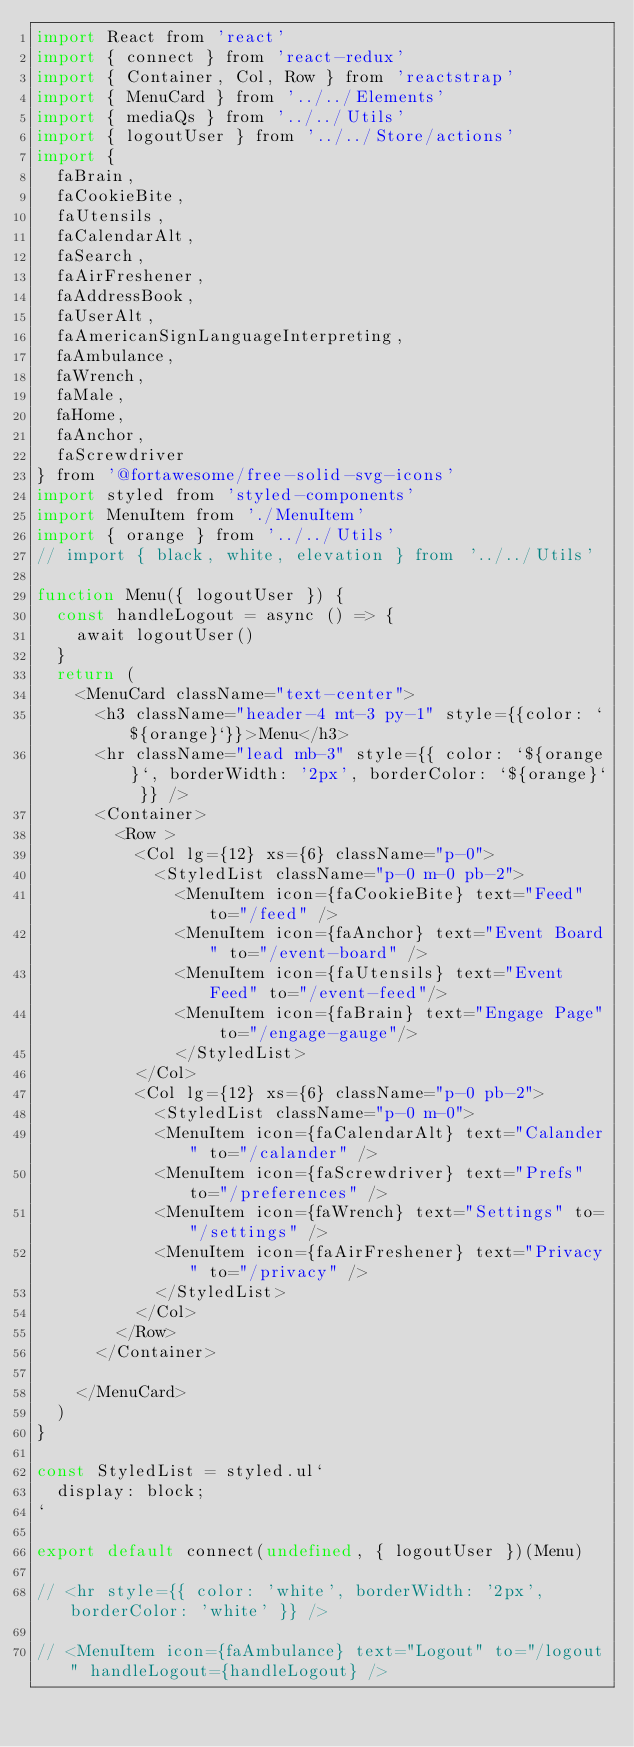<code> <loc_0><loc_0><loc_500><loc_500><_JavaScript_>import React from 'react'
import { connect } from 'react-redux'
import { Container, Col, Row } from 'reactstrap'
import { MenuCard } from '../../Elements'
import { mediaQs } from '../../Utils'
import { logoutUser } from '../../Store/actions'
import {
  faBrain,
  faCookieBite,
  faUtensils,
  faCalendarAlt,
  faSearch,
  faAirFreshener,
  faAddressBook,
  faUserAlt,
  faAmericanSignLanguageInterpreting,
  faAmbulance,
  faWrench,
  faMale,
  faHome,
  faAnchor,
  faScrewdriver
} from '@fortawesome/free-solid-svg-icons'
import styled from 'styled-components'
import MenuItem from './MenuItem'
import { orange } from '../../Utils'
// import { black, white, elevation } from '../../Utils'

function Menu({ logoutUser }) {
  const handleLogout = async () => {
    await logoutUser()
  }
  return (
    <MenuCard className="text-center">
      <h3 className="header-4 mt-3 py-1" style={{color: `${orange}`}}>Menu</h3>
      <hr className="lead mb-3" style={{ color: `${orange}`, borderWidth: '2px', borderColor: `${orange}` }} />
      <Container>
        <Row >
          <Col lg={12} xs={6} className="p-0">
            <StyledList className="p-0 m-0 pb-2">
              <MenuItem icon={faCookieBite} text="Feed" to="/feed" />
              <MenuItem icon={faAnchor} text="Event Board" to="/event-board" />
              <MenuItem icon={faUtensils} text="Event Feed" to="/event-feed"/>
              <MenuItem icon={faBrain} text="Engage Page" to="/engage-gauge"/>
              </StyledList>
          </Col>
          <Col lg={12} xs={6} className="p-0 pb-2">
            <StyledList className="p-0 m-0">
            <MenuItem icon={faCalendarAlt} text="Calander" to="/calander" />
            <MenuItem icon={faScrewdriver} text="Prefs" to="/preferences" />
            <MenuItem icon={faWrench} text="Settings" to="/settings" />
            <MenuItem icon={faAirFreshener} text="Privacy" to="/privacy" />
            </StyledList>
          </Col>
        </Row>
      </Container>
      
    </MenuCard>
  )
}

const StyledList = styled.ul`
  display: block;
`

export default connect(undefined, { logoutUser })(Menu)

// <hr style={{ color: 'white', borderWidth: '2px', borderColor: 'white' }} />

// <MenuItem icon={faAmbulance} text="Logout" to="/logout" handleLogout={handleLogout} /></code> 